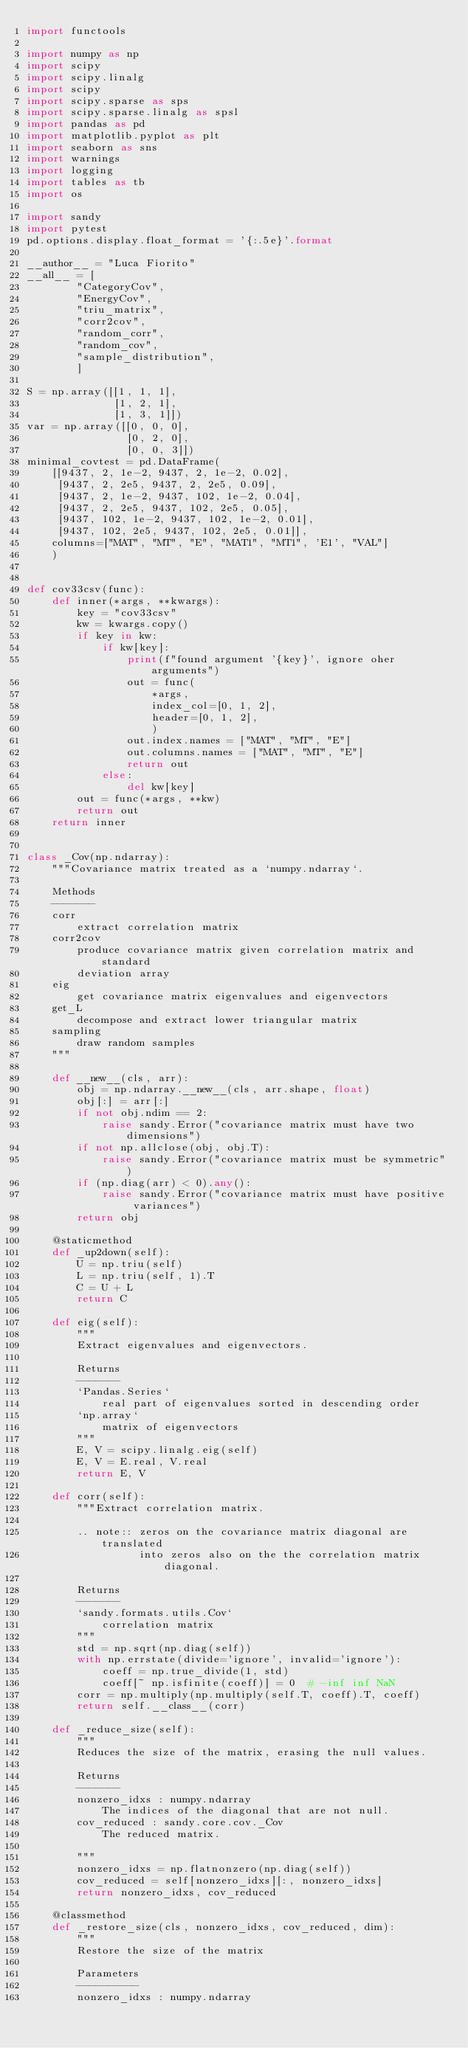<code> <loc_0><loc_0><loc_500><loc_500><_Python_>import functools

import numpy as np
import scipy
import scipy.linalg
import scipy
import scipy.sparse as sps
import scipy.sparse.linalg as spsl
import pandas as pd
import matplotlib.pyplot as plt
import seaborn as sns
import warnings
import logging
import tables as tb
import os

import sandy
import pytest
pd.options.display.float_format = '{:.5e}'.format

__author__ = "Luca Fiorito"
__all__ = [
        "CategoryCov",
        "EnergyCov",
        "triu_matrix",
        "corr2cov",
        "random_corr",
        "random_cov",
        "sample_distribution",
        ]

S = np.array([[1, 1, 1],
              [1, 2, 1],
              [1, 3, 1]])
var = np.array([[0, 0, 0],
                [0, 2, 0],
                [0, 0, 3]])
minimal_covtest = pd.DataFrame(
    [[9437, 2, 1e-2, 9437, 2, 1e-2, 0.02],
     [9437, 2, 2e5, 9437, 2, 2e5, 0.09],
     [9437, 2, 1e-2, 9437, 102, 1e-2, 0.04],
     [9437, 2, 2e5, 9437, 102, 2e5, 0.05],
     [9437, 102, 1e-2, 9437, 102, 1e-2, 0.01],
     [9437, 102, 2e5, 9437, 102, 2e5, 0.01]],
    columns=["MAT", "MT", "E", "MAT1", "MT1", 'E1', "VAL"]
    )


def cov33csv(func):
    def inner(*args, **kwargs):
        key = "cov33csv"
        kw = kwargs.copy()
        if key in kw:
            if kw[key]:
                print(f"found argument '{key}', ignore oher arguments")
                out = func(
                    *args,
                    index_col=[0, 1, 2],
                    header=[0, 1, 2],
                    )
                out.index.names = ["MAT", "MT", "E"]
                out.columns.names = ["MAT", "MT", "E"]
                return out
            else:
                del kw[key]
        out = func(*args, **kw)
        return out
    return inner


class _Cov(np.ndarray):
    """Covariance matrix treated as a `numpy.ndarray`.

    Methods
    -------
    corr
        extract correlation matrix
    corr2cov
        produce covariance matrix given correlation matrix and standard
        deviation array
    eig
        get covariance matrix eigenvalues and eigenvectors
    get_L
        decompose and extract lower triangular matrix
    sampling
        draw random samples
    """

    def __new__(cls, arr):
        obj = np.ndarray.__new__(cls, arr.shape, float)
        obj[:] = arr[:]
        if not obj.ndim == 2:
            raise sandy.Error("covariance matrix must have two dimensions")
        if not np.allclose(obj, obj.T):
            raise sandy.Error("covariance matrix must be symmetric")
        if (np.diag(arr) < 0).any():
            raise sandy.Error("covariance matrix must have positive variances")
        return obj

    @staticmethod
    def _up2down(self):
        U = np.triu(self)
        L = np.triu(self, 1).T
        C = U + L
        return C

    def eig(self):
        """
        Extract eigenvalues and eigenvectors.

        Returns
        -------
        `Pandas.Series`
            real part of eigenvalues sorted in descending order
        `np.array`
            matrix of eigenvectors
        """
        E, V = scipy.linalg.eig(self)
        E, V = E.real, V.real
        return E, V

    def corr(self):
        """Extract correlation matrix.

        .. note:: zeros on the covariance matrix diagonal are translated
                  into zeros also on the the correlation matrix diagonal.

        Returns
        -------
        `sandy.formats.utils.Cov`
            correlation matrix
        """
        std = np.sqrt(np.diag(self))
        with np.errstate(divide='ignore', invalid='ignore'):
            coeff = np.true_divide(1, std)
            coeff[~ np.isfinite(coeff)] = 0  # -inf inf NaN
        corr = np.multiply(np.multiply(self.T, coeff).T, coeff)
        return self.__class__(corr)

    def _reduce_size(self):
        """
        Reduces the size of the matrix, erasing the null values.

        Returns
        -------
        nonzero_idxs : numpy.ndarray
            The indices of the diagonal that are not null.
        cov_reduced : sandy.core.cov._Cov
            The reduced matrix.

        """
        nonzero_idxs = np.flatnonzero(np.diag(self))
        cov_reduced = self[nonzero_idxs][:, nonzero_idxs]
        return nonzero_idxs, cov_reduced

    @classmethod
    def _restore_size(cls, nonzero_idxs, cov_reduced, dim):
        """
        Restore the size of the matrix

        Parameters
        ----------
        nonzero_idxs : numpy.ndarray</code> 